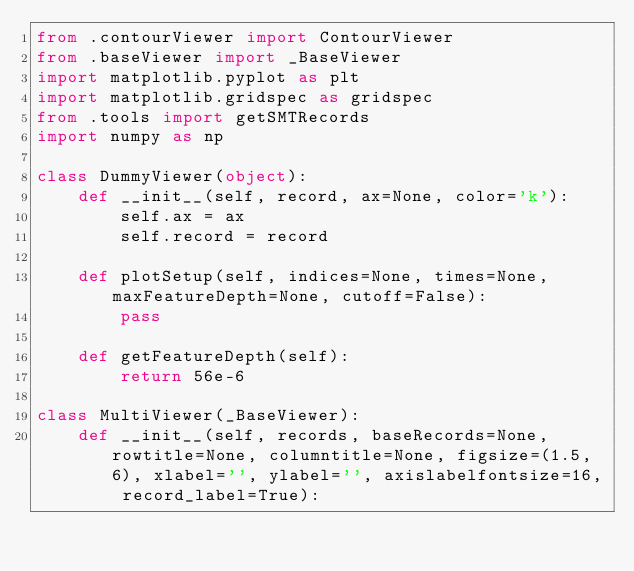Convert code to text. <code><loc_0><loc_0><loc_500><loc_500><_Python_>from .contourViewer import ContourViewer
from .baseViewer import _BaseViewer
import matplotlib.pyplot as plt
import matplotlib.gridspec as gridspec
from .tools import getSMTRecords
import numpy as np

class DummyViewer(object):
    def __init__(self, record, ax=None, color='k'):
        self.ax = ax
        self.record = record

    def plotSetup(self, indices=None, times=None, maxFeatureDepth=None, cutoff=False):
        pass

    def getFeatureDepth(self):
        return 56e-6

class MultiViewer(_BaseViewer):
    def __init__(self, records, baseRecords=None, rowtitle=None, columntitle=None, figsize=(1.5, 6), xlabel='', ylabel='', axislabelfontsize=16, record_label=True):</code> 